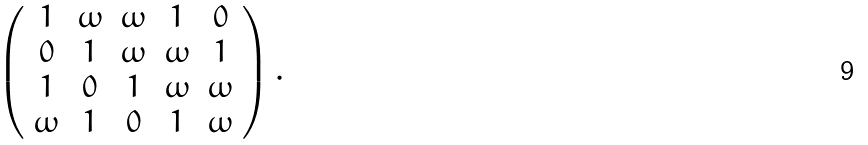Convert formula to latex. <formula><loc_0><loc_0><loc_500><loc_500>\left ( \begin{array} { c c c c c } 1 & \omega & \omega & 1 & 0 \\ 0 & 1 & \omega & \omega & 1 \\ 1 & 0 & 1 & \omega & \omega \\ \omega & 1 & 0 & 1 & \omega \end{array} \right ) .</formula> 